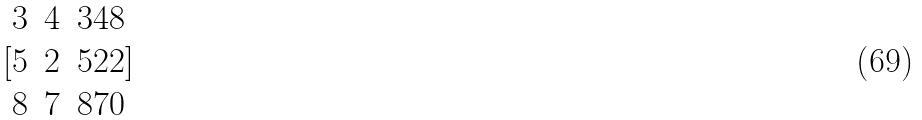<formula> <loc_0><loc_0><loc_500><loc_500>[ \begin{matrix} 3 & 4 & 3 4 8 \\ 5 & 2 & 5 2 2 \\ 8 & 7 & 8 7 0 \end{matrix} ]</formula> 